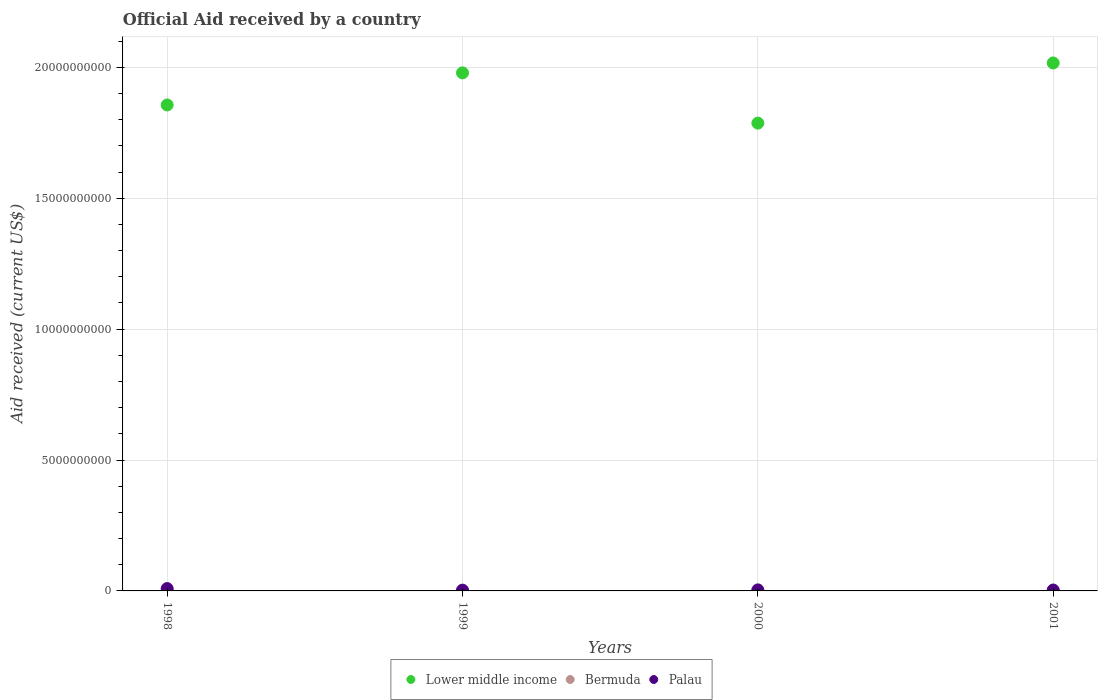How many different coloured dotlines are there?
Your answer should be compact. 3. What is the net official aid received in Lower middle income in 1999?
Offer a terse response. 1.98e+1. Across all years, what is the maximum net official aid received in Palau?
Provide a short and direct response. 8.91e+07. Across all years, what is the minimum net official aid received in Palau?
Offer a terse response. 2.88e+07. In which year was the net official aid received in Lower middle income minimum?
Give a very brief answer. 2000. What is the total net official aid received in Palau in the graph?
Your answer should be compact. 1.92e+08. What is the difference between the net official aid received in Lower middle income in 1998 and that in 2001?
Make the answer very short. -1.60e+09. What is the difference between the net official aid received in Palau in 1998 and the net official aid received in Bermuda in 2001?
Offer a very short reply. 8.91e+07. What is the average net official aid received in Palau per year?
Ensure brevity in your answer.  4.79e+07. In the year 2001, what is the difference between the net official aid received in Palau and net official aid received in Bermuda?
Offer a very short reply. 3.45e+07. What is the ratio of the net official aid received in Palau in 1999 to that in 2000?
Keep it short and to the point. 0.74. Is the difference between the net official aid received in Palau in 1998 and 1999 greater than the difference between the net official aid received in Bermuda in 1998 and 1999?
Give a very brief answer. Yes. What is the difference between the highest and the second highest net official aid received in Palau?
Your answer should be very brief. 5.00e+07. What is the difference between the highest and the lowest net official aid received in Bermuda?
Your response must be concise. 5.30e+05. Is it the case that in every year, the sum of the net official aid received in Lower middle income and net official aid received in Bermuda  is greater than the net official aid received in Palau?
Provide a short and direct response. Yes. Is the net official aid received in Lower middle income strictly greater than the net official aid received in Palau over the years?
Your response must be concise. Yes. How many years are there in the graph?
Make the answer very short. 4. Are the values on the major ticks of Y-axis written in scientific E-notation?
Your response must be concise. No. Does the graph contain any zero values?
Your response must be concise. No. How are the legend labels stacked?
Ensure brevity in your answer.  Horizontal. What is the title of the graph?
Provide a succinct answer. Official Aid received by a country. What is the label or title of the Y-axis?
Your answer should be very brief. Aid received (current US$). What is the Aid received (current US$) in Lower middle income in 1998?
Offer a very short reply. 1.86e+1. What is the Aid received (current US$) in Palau in 1998?
Provide a succinct answer. 8.91e+07. What is the Aid received (current US$) of Lower middle income in 1999?
Your response must be concise. 1.98e+1. What is the Aid received (current US$) of Bermuda in 1999?
Provide a short and direct response. 8.00e+04. What is the Aid received (current US$) of Palau in 1999?
Give a very brief answer. 2.88e+07. What is the Aid received (current US$) in Lower middle income in 2000?
Offer a terse response. 1.79e+1. What is the Aid received (current US$) in Bermuda in 2000?
Ensure brevity in your answer.  6.00e+04. What is the Aid received (current US$) of Palau in 2000?
Provide a short and direct response. 3.91e+07. What is the Aid received (current US$) in Lower middle income in 2001?
Ensure brevity in your answer.  2.02e+1. What is the Aid received (current US$) of Bermuda in 2001?
Provide a succinct answer. 2.00e+04. What is the Aid received (current US$) of Palau in 2001?
Your answer should be very brief. 3.45e+07. Across all years, what is the maximum Aid received (current US$) of Lower middle income?
Give a very brief answer. 2.02e+1. Across all years, what is the maximum Aid received (current US$) of Palau?
Your answer should be compact. 8.91e+07. Across all years, what is the minimum Aid received (current US$) of Lower middle income?
Give a very brief answer. 1.79e+1. Across all years, what is the minimum Aid received (current US$) in Bermuda?
Offer a very short reply. 2.00e+04. Across all years, what is the minimum Aid received (current US$) of Palau?
Provide a short and direct response. 2.88e+07. What is the total Aid received (current US$) of Lower middle income in the graph?
Provide a succinct answer. 7.64e+1. What is the total Aid received (current US$) in Bermuda in the graph?
Provide a succinct answer. 7.10e+05. What is the total Aid received (current US$) in Palau in the graph?
Provide a short and direct response. 1.92e+08. What is the difference between the Aid received (current US$) in Lower middle income in 1998 and that in 1999?
Offer a terse response. -1.23e+09. What is the difference between the Aid received (current US$) of Palau in 1998 and that in 1999?
Provide a short and direct response. 6.03e+07. What is the difference between the Aid received (current US$) of Lower middle income in 1998 and that in 2000?
Offer a very short reply. 6.93e+08. What is the difference between the Aid received (current US$) of Bermuda in 1998 and that in 2000?
Provide a short and direct response. 4.90e+05. What is the difference between the Aid received (current US$) in Palau in 1998 and that in 2000?
Offer a terse response. 5.00e+07. What is the difference between the Aid received (current US$) in Lower middle income in 1998 and that in 2001?
Offer a terse response. -1.60e+09. What is the difference between the Aid received (current US$) of Bermuda in 1998 and that in 2001?
Offer a terse response. 5.30e+05. What is the difference between the Aid received (current US$) in Palau in 1998 and that in 2001?
Offer a terse response. 5.46e+07. What is the difference between the Aid received (current US$) in Lower middle income in 1999 and that in 2000?
Your answer should be compact. 1.92e+09. What is the difference between the Aid received (current US$) in Palau in 1999 and that in 2000?
Provide a succinct answer. -1.03e+07. What is the difference between the Aid received (current US$) in Lower middle income in 1999 and that in 2001?
Your answer should be very brief. -3.77e+08. What is the difference between the Aid received (current US$) of Palau in 1999 and that in 2001?
Provide a succinct answer. -5.65e+06. What is the difference between the Aid received (current US$) of Lower middle income in 2000 and that in 2001?
Provide a short and direct response. -2.30e+09. What is the difference between the Aid received (current US$) in Bermuda in 2000 and that in 2001?
Offer a very short reply. 4.00e+04. What is the difference between the Aid received (current US$) in Palau in 2000 and that in 2001?
Provide a short and direct response. 4.64e+06. What is the difference between the Aid received (current US$) of Lower middle income in 1998 and the Aid received (current US$) of Bermuda in 1999?
Provide a short and direct response. 1.86e+1. What is the difference between the Aid received (current US$) of Lower middle income in 1998 and the Aid received (current US$) of Palau in 1999?
Offer a terse response. 1.85e+1. What is the difference between the Aid received (current US$) of Bermuda in 1998 and the Aid received (current US$) of Palau in 1999?
Your answer should be very brief. -2.83e+07. What is the difference between the Aid received (current US$) in Lower middle income in 1998 and the Aid received (current US$) in Bermuda in 2000?
Your answer should be very brief. 1.86e+1. What is the difference between the Aid received (current US$) in Lower middle income in 1998 and the Aid received (current US$) in Palau in 2000?
Keep it short and to the point. 1.85e+1. What is the difference between the Aid received (current US$) of Bermuda in 1998 and the Aid received (current US$) of Palau in 2000?
Keep it short and to the point. -3.86e+07. What is the difference between the Aid received (current US$) of Lower middle income in 1998 and the Aid received (current US$) of Bermuda in 2001?
Your response must be concise. 1.86e+1. What is the difference between the Aid received (current US$) of Lower middle income in 1998 and the Aid received (current US$) of Palau in 2001?
Keep it short and to the point. 1.85e+1. What is the difference between the Aid received (current US$) in Bermuda in 1998 and the Aid received (current US$) in Palau in 2001?
Make the answer very short. -3.39e+07. What is the difference between the Aid received (current US$) of Lower middle income in 1999 and the Aid received (current US$) of Bermuda in 2000?
Give a very brief answer. 1.98e+1. What is the difference between the Aid received (current US$) of Lower middle income in 1999 and the Aid received (current US$) of Palau in 2000?
Your response must be concise. 1.97e+1. What is the difference between the Aid received (current US$) in Bermuda in 1999 and the Aid received (current US$) in Palau in 2000?
Keep it short and to the point. -3.90e+07. What is the difference between the Aid received (current US$) of Lower middle income in 1999 and the Aid received (current US$) of Bermuda in 2001?
Your response must be concise. 1.98e+1. What is the difference between the Aid received (current US$) in Lower middle income in 1999 and the Aid received (current US$) in Palau in 2001?
Your response must be concise. 1.98e+1. What is the difference between the Aid received (current US$) in Bermuda in 1999 and the Aid received (current US$) in Palau in 2001?
Your response must be concise. -3.44e+07. What is the difference between the Aid received (current US$) in Lower middle income in 2000 and the Aid received (current US$) in Bermuda in 2001?
Ensure brevity in your answer.  1.79e+1. What is the difference between the Aid received (current US$) in Lower middle income in 2000 and the Aid received (current US$) in Palau in 2001?
Your answer should be very brief. 1.78e+1. What is the difference between the Aid received (current US$) of Bermuda in 2000 and the Aid received (current US$) of Palau in 2001?
Ensure brevity in your answer.  -3.44e+07. What is the average Aid received (current US$) of Lower middle income per year?
Your answer should be compact. 1.91e+1. What is the average Aid received (current US$) of Bermuda per year?
Offer a very short reply. 1.78e+05. What is the average Aid received (current US$) in Palau per year?
Provide a short and direct response. 4.79e+07. In the year 1998, what is the difference between the Aid received (current US$) of Lower middle income and Aid received (current US$) of Bermuda?
Offer a terse response. 1.86e+1. In the year 1998, what is the difference between the Aid received (current US$) of Lower middle income and Aid received (current US$) of Palau?
Offer a very short reply. 1.85e+1. In the year 1998, what is the difference between the Aid received (current US$) in Bermuda and Aid received (current US$) in Palau?
Give a very brief answer. -8.86e+07. In the year 1999, what is the difference between the Aid received (current US$) of Lower middle income and Aid received (current US$) of Bermuda?
Make the answer very short. 1.98e+1. In the year 1999, what is the difference between the Aid received (current US$) in Lower middle income and Aid received (current US$) in Palau?
Your response must be concise. 1.98e+1. In the year 1999, what is the difference between the Aid received (current US$) in Bermuda and Aid received (current US$) in Palau?
Provide a succinct answer. -2.88e+07. In the year 2000, what is the difference between the Aid received (current US$) in Lower middle income and Aid received (current US$) in Bermuda?
Your answer should be very brief. 1.79e+1. In the year 2000, what is the difference between the Aid received (current US$) of Lower middle income and Aid received (current US$) of Palau?
Offer a terse response. 1.78e+1. In the year 2000, what is the difference between the Aid received (current US$) in Bermuda and Aid received (current US$) in Palau?
Provide a short and direct response. -3.91e+07. In the year 2001, what is the difference between the Aid received (current US$) of Lower middle income and Aid received (current US$) of Bermuda?
Your answer should be very brief. 2.02e+1. In the year 2001, what is the difference between the Aid received (current US$) of Lower middle income and Aid received (current US$) of Palau?
Your answer should be very brief. 2.01e+1. In the year 2001, what is the difference between the Aid received (current US$) of Bermuda and Aid received (current US$) of Palau?
Provide a succinct answer. -3.45e+07. What is the ratio of the Aid received (current US$) in Lower middle income in 1998 to that in 1999?
Offer a very short reply. 0.94. What is the ratio of the Aid received (current US$) of Bermuda in 1998 to that in 1999?
Offer a very short reply. 6.88. What is the ratio of the Aid received (current US$) of Palau in 1998 to that in 1999?
Give a very brief answer. 3.09. What is the ratio of the Aid received (current US$) in Lower middle income in 1998 to that in 2000?
Make the answer very short. 1.04. What is the ratio of the Aid received (current US$) of Bermuda in 1998 to that in 2000?
Provide a succinct answer. 9.17. What is the ratio of the Aid received (current US$) in Palau in 1998 to that in 2000?
Provide a succinct answer. 2.28. What is the ratio of the Aid received (current US$) in Lower middle income in 1998 to that in 2001?
Your answer should be very brief. 0.92. What is the ratio of the Aid received (current US$) in Bermuda in 1998 to that in 2001?
Ensure brevity in your answer.  27.5. What is the ratio of the Aid received (current US$) in Palau in 1998 to that in 2001?
Make the answer very short. 2.58. What is the ratio of the Aid received (current US$) of Lower middle income in 1999 to that in 2000?
Provide a short and direct response. 1.11. What is the ratio of the Aid received (current US$) of Palau in 1999 to that in 2000?
Provide a short and direct response. 0.74. What is the ratio of the Aid received (current US$) of Lower middle income in 1999 to that in 2001?
Your response must be concise. 0.98. What is the ratio of the Aid received (current US$) of Palau in 1999 to that in 2001?
Offer a terse response. 0.84. What is the ratio of the Aid received (current US$) of Lower middle income in 2000 to that in 2001?
Offer a terse response. 0.89. What is the ratio of the Aid received (current US$) of Bermuda in 2000 to that in 2001?
Provide a succinct answer. 3. What is the ratio of the Aid received (current US$) of Palau in 2000 to that in 2001?
Offer a very short reply. 1.13. What is the difference between the highest and the second highest Aid received (current US$) of Lower middle income?
Offer a terse response. 3.77e+08. What is the difference between the highest and the second highest Aid received (current US$) in Bermuda?
Provide a short and direct response. 4.70e+05. What is the difference between the highest and the second highest Aid received (current US$) of Palau?
Provide a short and direct response. 5.00e+07. What is the difference between the highest and the lowest Aid received (current US$) of Lower middle income?
Provide a short and direct response. 2.30e+09. What is the difference between the highest and the lowest Aid received (current US$) in Bermuda?
Provide a short and direct response. 5.30e+05. What is the difference between the highest and the lowest Aid received (current US$) in Palau?
Your response must be concise. 6.03e+07. 